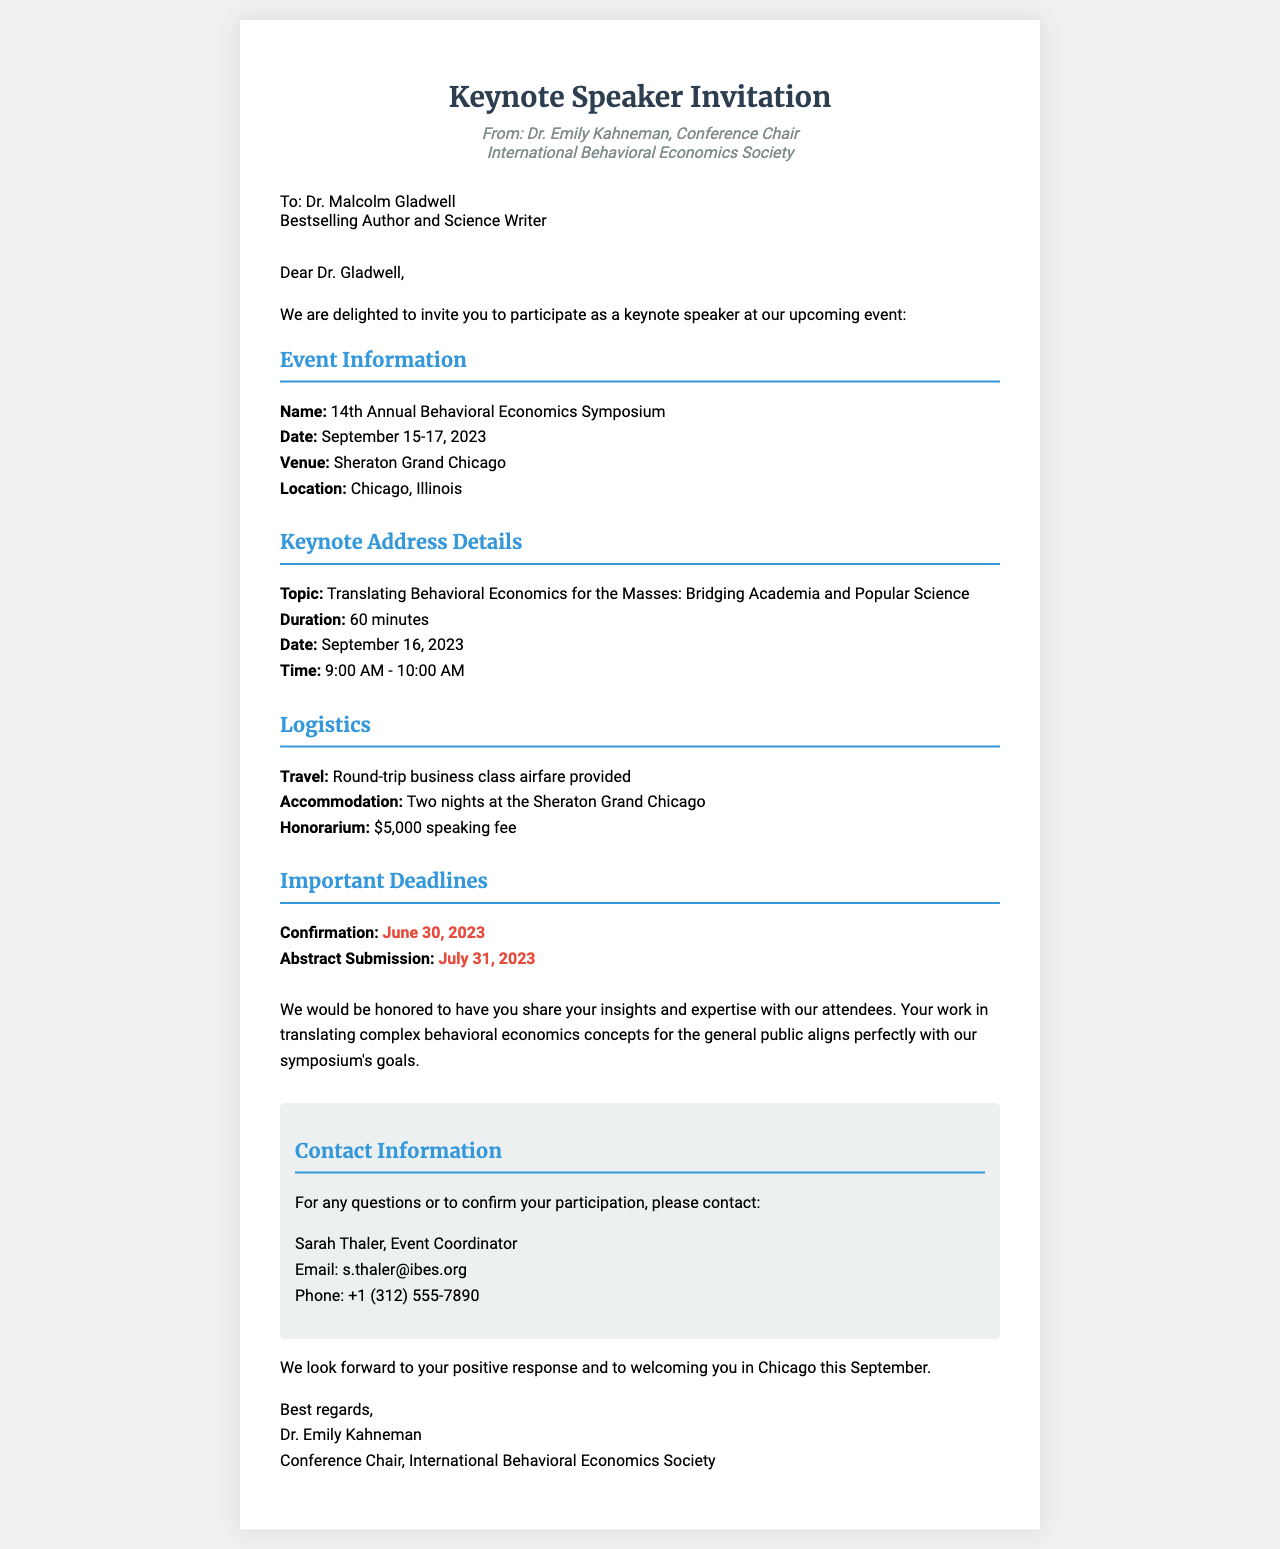What is the name of the event? The event is referred to as the 14th Annual Behavioral Economics Symposium in the document.
Answer: 14th Annual Behavioral Economics Symposium What are the event dates? The document specifies the event dates as September 15-17, 2023.
Answer: September 15-17, 2023 Who is the intended recipient of the invitation? The recipient named in the document is Dr. Malcolm Gladwell.
Answer: Dr. Malcolm Gladwell What is the duration of the keynote address? The keynote address is noted to have a duration of 60 minutes in the document.
Answer: 60 minutes What is the honorarium for the keynote speaker? The document states that the honorarium is $5,000.
Answer: $5,000 What is the confirmation deadline? The document highlights June 30, 2023, as the confirmation deadline.
Answer: June 30, 2023 What topic will the keynote address cover? The topic of the keynote address is outlined as "Translating Behavioral Economics for the Masses: Bridging Academia and Popular Science."
Answer: Translating Behavioral Economics for the Masses: Bridging Academia and Popular Science What type of airfare is provided? The document states that round-trip business class airfare will be provided to the keynote speaker.
Answer: Round-trip business class airfare Who is the event coordinator? The document names Sarah Thaler as the event coordinator.
Answer: Sarah Thaler 